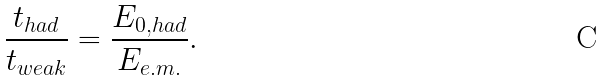<formula> <loc_0><loc_0><loc_500><loc_500>\frac { t _ { h a d } } { t _ { w e a k } } = \frac { E _ { 0 , h a d } } { E _ { e . m . } } .</formula> 